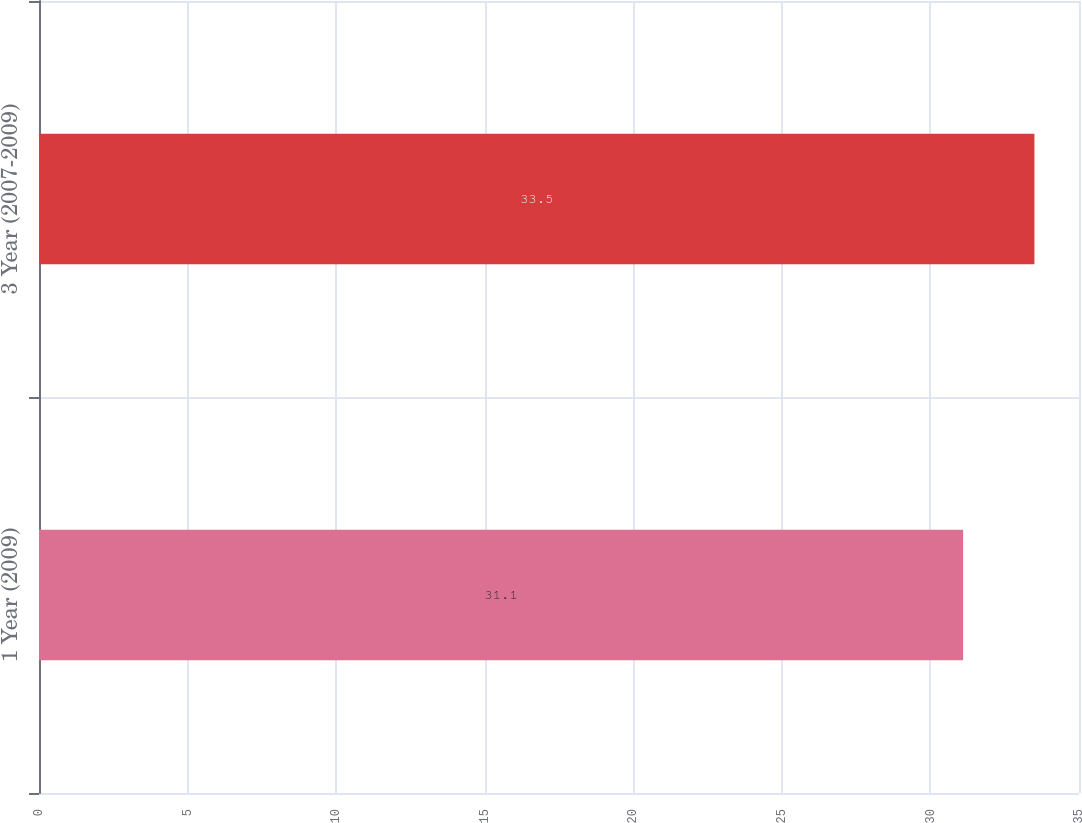Convert chart. <chart><loc_0><loc_0><loc_500><loc_500><bar_chart><fcel>1 Year (2009)<fcel>3 Year (2007-2009)<nl><fcel>31.1<fcel>33.5<nl></chart> 